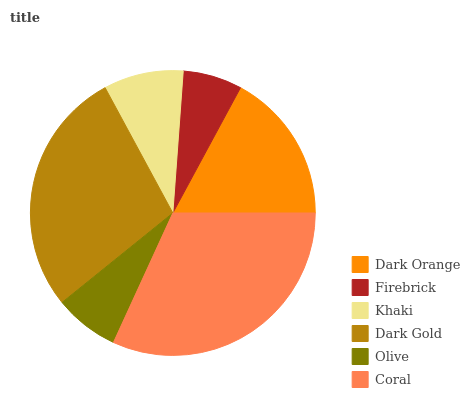Is Firebrick the minimum?
Answer yes or no. Yes. Is Coral the maximum?
Answer yes or no. Yes. Is Khaki the minimum?
Answer yes or no. No. Is Khaki the maximum?
Answer yes or no. No. Is Khaki greater than Firebrick?
Answer yes or no. Yes. Is Firebrick less than Khaki?
Answer yes or no. Yes. Is Firebrick greater than Khaki?
Answer yes or no. No. Is Khaki less than Firebrick?
Answer yes or no. No. Is Dark Orange the high median?
Answer yes or no. Yes. Is Khaki the low median?
Answer yes or no. Yes. Is Firebrick the high median?
Answer yes or no. No. Is Coral the low median?
Answer yes or no. No. 